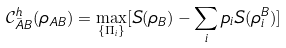<formula> <loc_0><loc_0><loc_500><loc_500>\mathcal { C } ^ { h } _ { \bar { A } B } ( \rho _ { A B } ) = \max _ { \{ \Pi _ { i } \} } [ S ( \rho _ { B } ) - \sum _ { i } p _ { i } S ( \rho _ { i } ^ { B } ) ]</formula> 